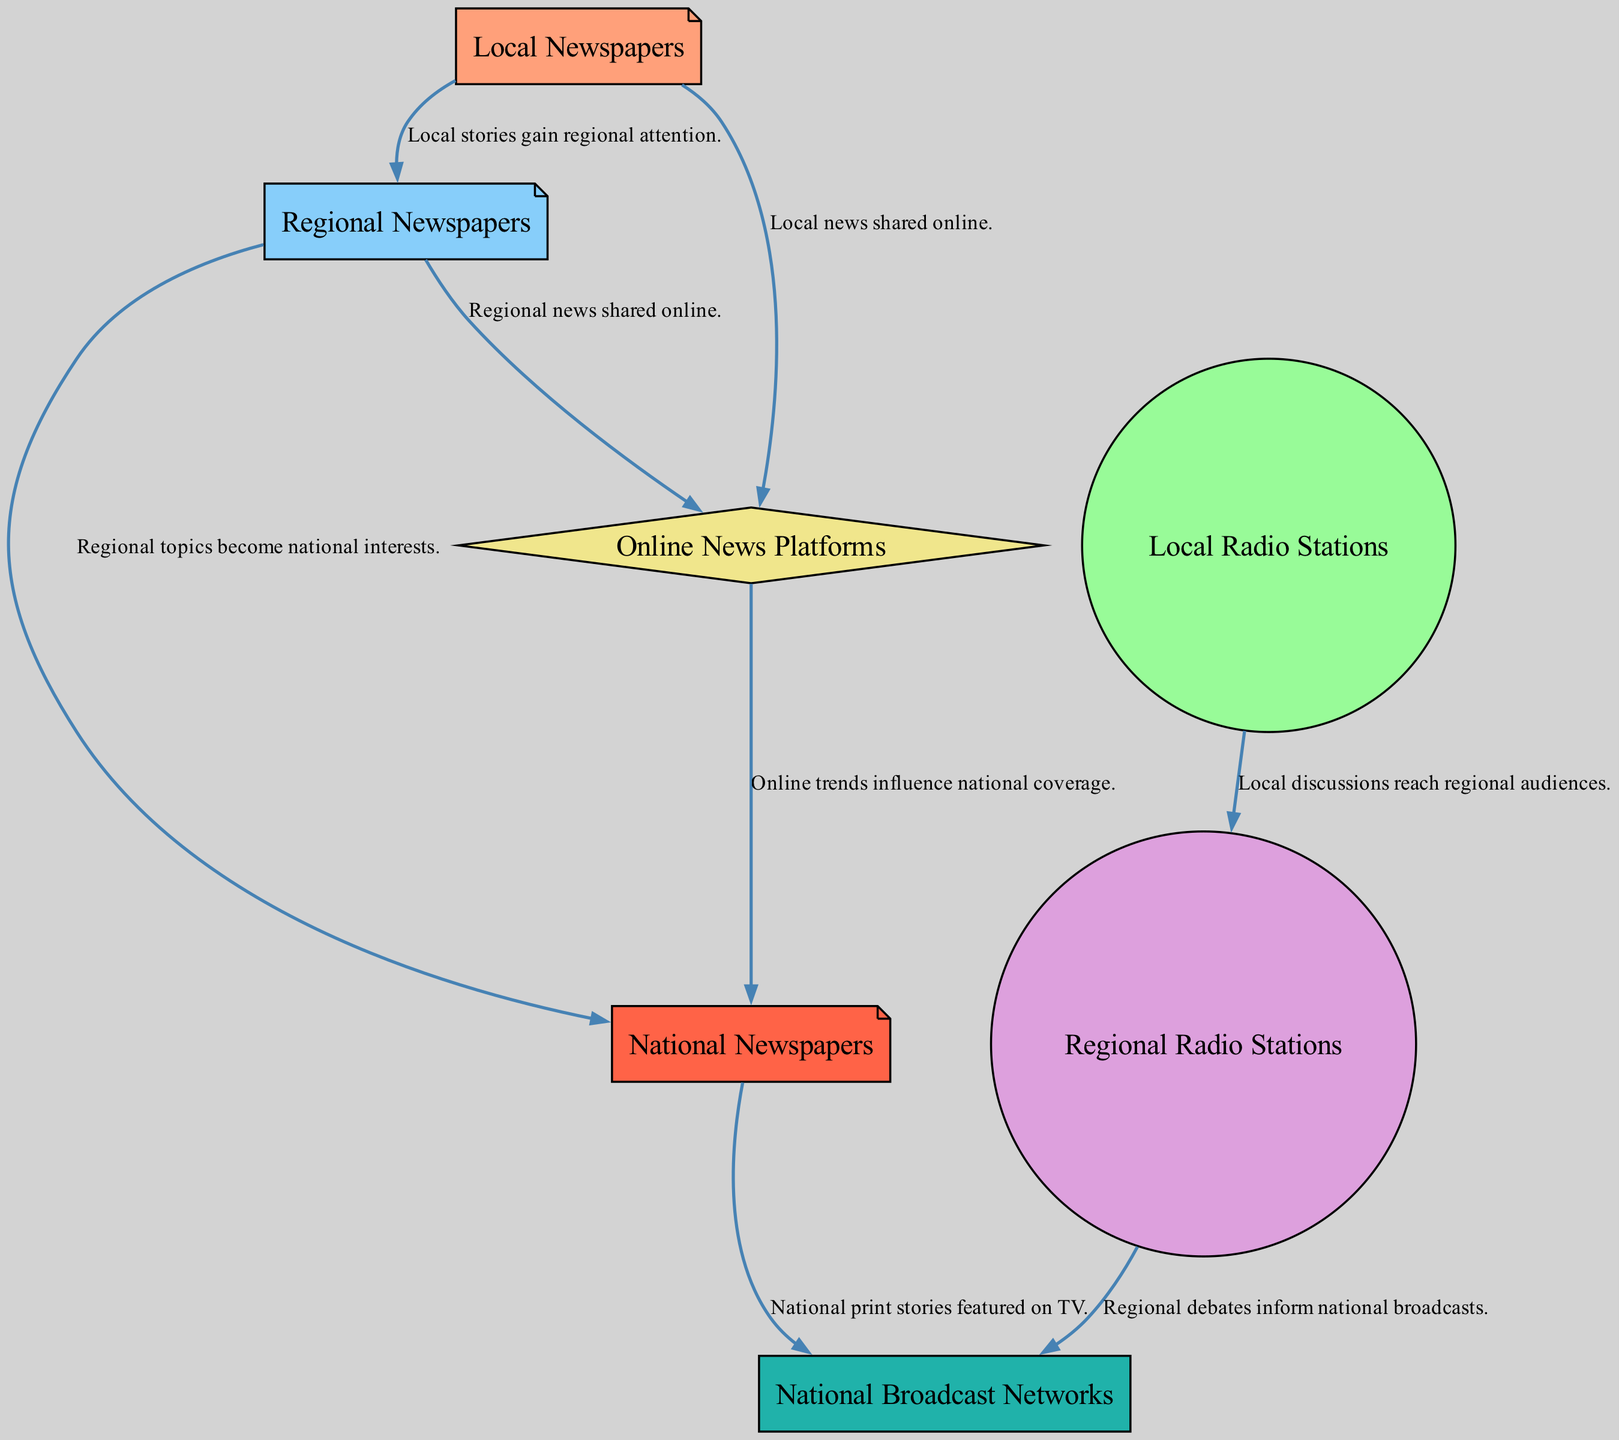What is the first node in the food chain? The first node listed in the diagram is "Local Newspapers," which indicates the starting point of the media influence food chain.
Answer: Local Newspapers How many nodes are in the diagram? The diagram includes a total of 7 nodes, which represent different forms of media influencing political coverage.
Answer: 7 What type of media amplifies local stories? Regional Newspapers are the type of media that amplify local stories to reach a broader audience.
Answer: Regional Newspapers Which node comes after Local Radio Stations in the food chain? Local Radio Stations connect to Regional Radio Stations, indicating the next step in the media influence chain.
Answer: Regional Radio Stations What type of media disseminates news through social media? Online News Platforms are responsible for disseminating local and regional news through social media and websites.
Answer: Online News Platforms How many edges originate from Regional Newspapers? Regional Newspapers have 3 outgoing edges that lead to Online Media, National Newspapers, and they also connect to Regional Radio Stations.
Answer: 3 Which node receives influence from both Regional Radio Stations and National Newspapers? Broadcast Networks receive influence from both Regional Radio Stations and National Newspapers as indicated by the edges leading to it.
Answer: Broadcast Networks What do Online News Platforms influence at a national level? Online News Platforms influence National Newspapers by affecting the coverage of national stories based on online trends.
Answer: National Newspapers Which node does not have any outgoing edges? The last node in the food chain, Broadcast Networks, does not have any outgoing edges, as it is the endpoint of the influence chain.
Answer: Broadcast Networks 